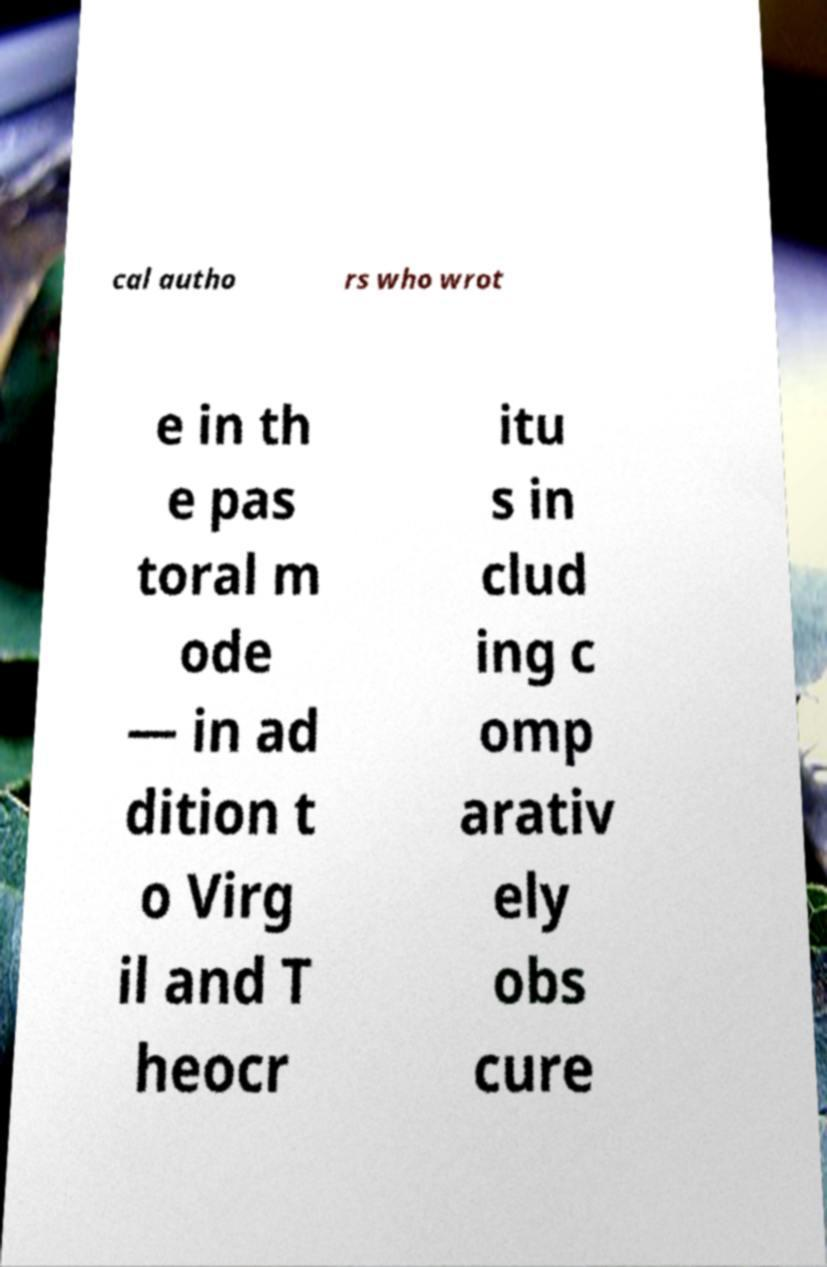I need the written content from this picture converted into text. Can you do that? cal autho rs who wrot e in th e pas toral m ode — in ad dition t o Virg il and T heocr itu s in clud ing c omp arativ ely obs cure 